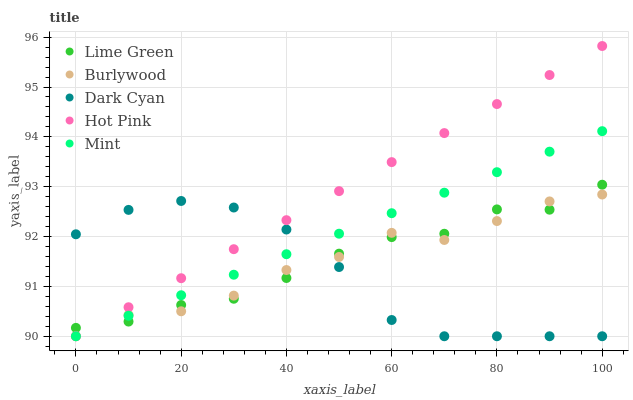Does Dark Cyan have the minimum area under the curve?
Answer yes or no. Yes. Does Hot Pink have the maximum area under the curve?
Answer yes or no. Yes. Does Hot Pink have the minimum area under the curve?
Answer yes or no. No. Does Dark Cyan have the maximum area under the curve?
Answer yes or no. No. Is Hot Pink the smoothest?
Answer yes or no. Yes. Is Burlywood the roughest?
Answer yes or no. Yes. Is Dark Cyan the smoothest?
Answer yes or no. No. Is Dark Cyan the roughest?
Answer yes or no. No. Does Burlywood have the lowest value?
Answer yes or no. Yes. Does Lime Green have the lowest value?
Answer yes or no. No. Does Hot Pink have the highest value?
Answer yes or no. Yes. Does Dark Cyan have the highest value?
Answer yes or no. No. Does Lime Green intersect Mint?
Answer yes or no. Yes. Is Lime Green less than Mint?
Answer yes or no. No. Is Lime Green greater than Mint?
Answer yes or no. No. 